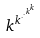<formula> <loc_0><loc_0><loc_500><loc_500>k ^ { k ^ { \cdot ^ { \cdot ^ { k ^ { k } } } } }</formula> 